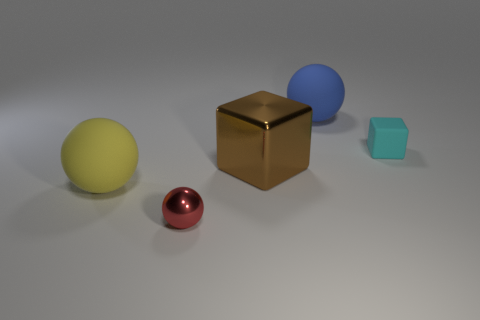What materials do the objects in the image seem to be made of? The objects in the image appear to be made of different materials. The larger spheres suggest a matte finish, possibly plastic, with the yellow having a glossy texture like a polished metal. The smaller sphere has a reflective surface that could indicate a metallic material. The closest cube to us has a mirrored finish and appears golden in color, suggesting a polished metal, while the smallest cube seems to be made of a matte material such as light blue plastic. 